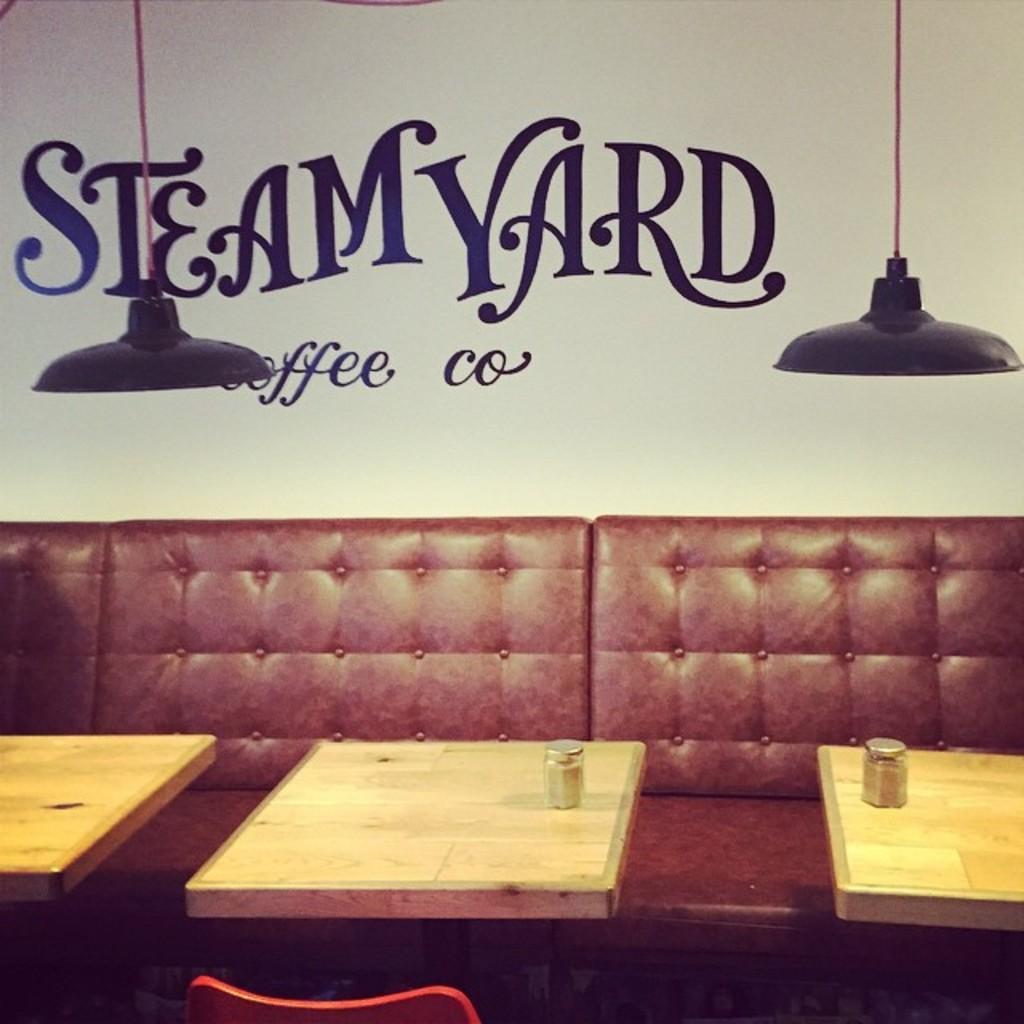How would you summarize this image in a sentence or two? In this picture we can see sofa and in front of it tables and on table we have jars, chair and in background we can see wall, ,lights and it is a poster. 